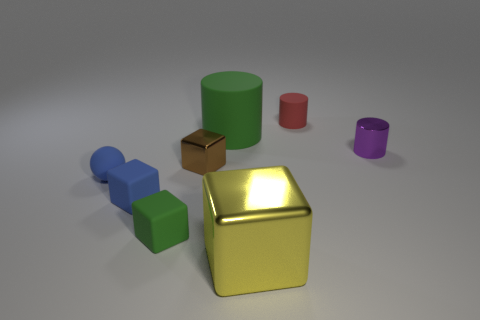There is a rubber object that is the same color as the tiny matte ball; what is its size?
Keep it short and to the point. Small. There is a blue matte thing that is behind the small blue matte object to the right of the small sphere; what number of large yellow metal things are in front of it?
Make the answer very short. 1. Does the big metallic object have the same color as the large cylinder?
Ensure brevity in your answer.  No. Is there a tiny object that has the same color as the rubber ball?
Your answer should be very brief. Yes. What is the color of the metallic cube that is the same size as the purple shiny thing?
Offer a very short reply. Brown. Are there any blue objects that have the same shape as the big yellow metallic object?
Offer a terse response. Yes. The object that is the same color as the rubber sphere is what shape?
Your answer should be very brief. Cube. Is there a small brown shiny thing behind the metal object right of the small object that is behind the big green cylinder?
Make the answer very short. No. There is a brown metal object that is the same size as the blue sphere; what shape is it?
Give a very brief answer. Cube. There is a big thing that is the same shape as the tiny brown shiny thing; what color is it?
Your response must be concise. Yellow. 